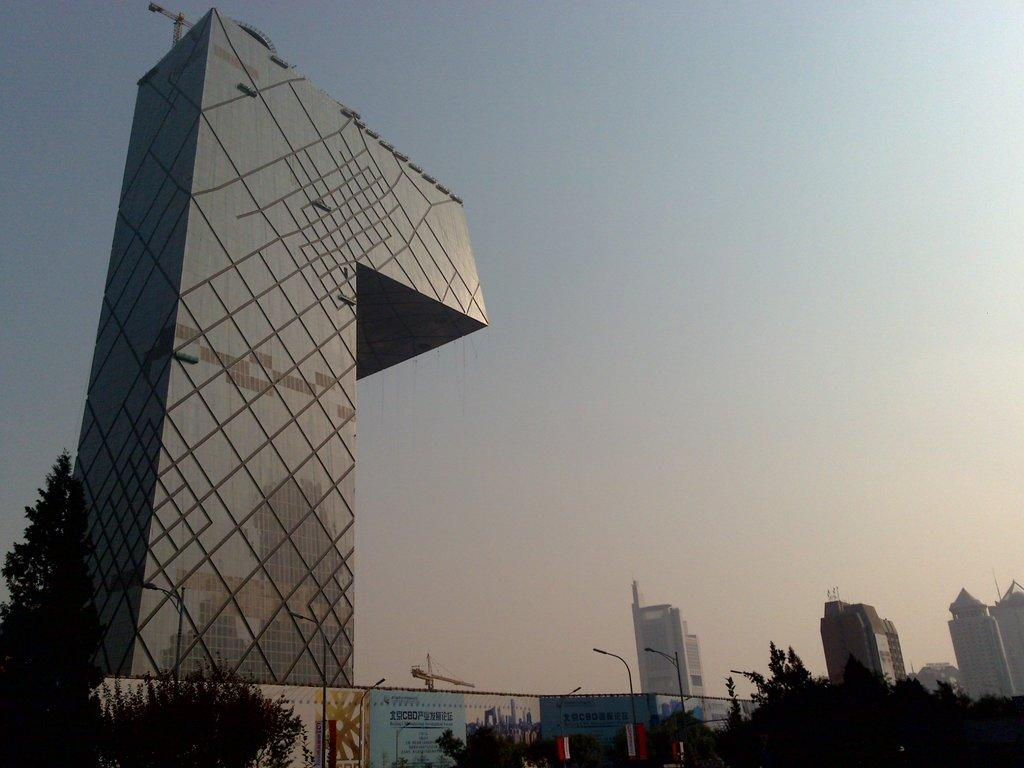What type of vegetation is visible in the front of the image? There are trees in the front of the image. What type of signage can be seen in the image? There are banners in the image. What type of lighting is present in the image? There are street lights in the image. What mode of transportation is present in the image? There is a train in the image. What type of structures are visible in the background of the image? There are buildings in the background of the image. What is visible in the sky in the background of the image? The sky is visible in the background of the image. What substance is being kicked in the image? There is no substance being kicked in the image. What is the purpose of the train in the image? The purpose of the train in the image cannot be determined from the image alone. 